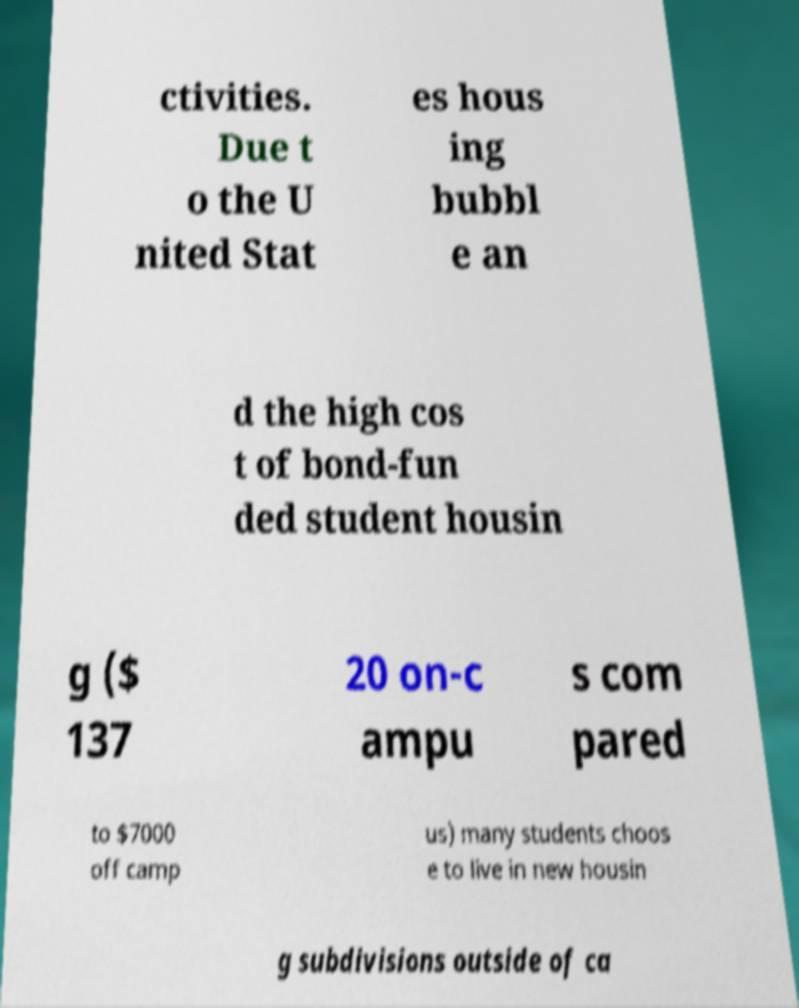What messages or text are displayed in this image? I need them in a readable, typed format. ctivities. Due t o the U nited Stat es hous ing bubbl e an d the high cos t of bond-fun ded student housin g ($ 137 20 on-c ampu s com pared to $7000 off camp us) many students choos e to live in new housin g subdivisions outside of ca 